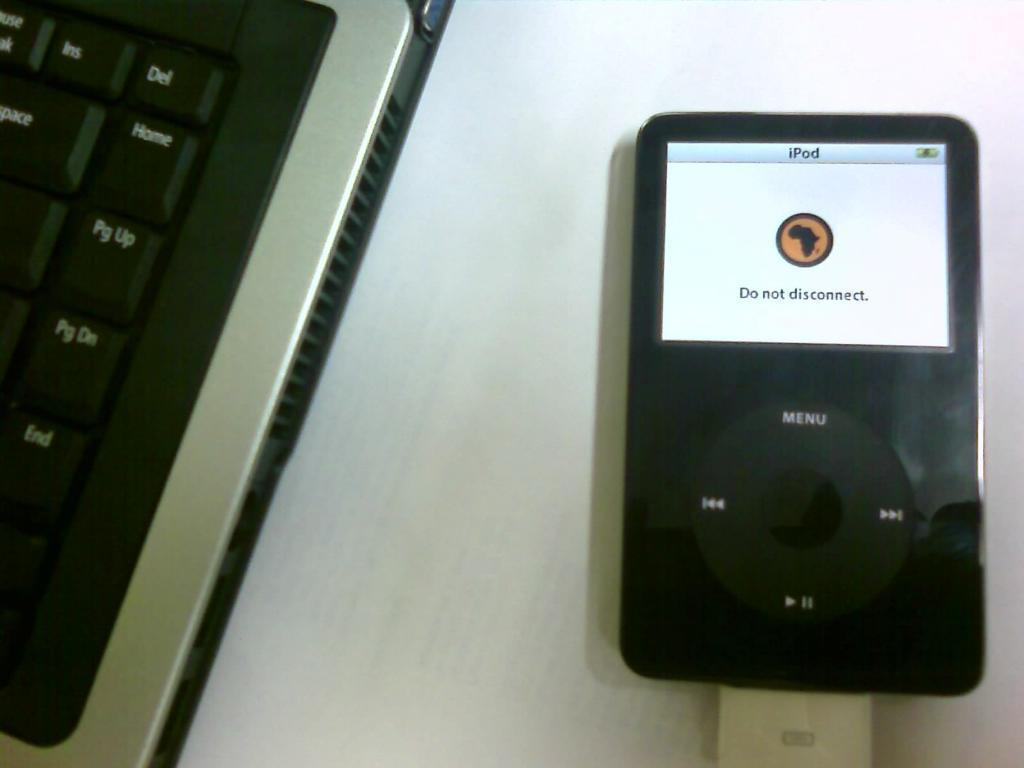What electronic device is visible in the image? There is a keyboard in the image. What other electronic device can be seen in the image? There is an iPod in the image. What type of church is depicted in the image? There is no church present in the image; it only features a keyboard and an iPod. How many cobwebs can be seen in the image? There are no cobwebs present in the image. 